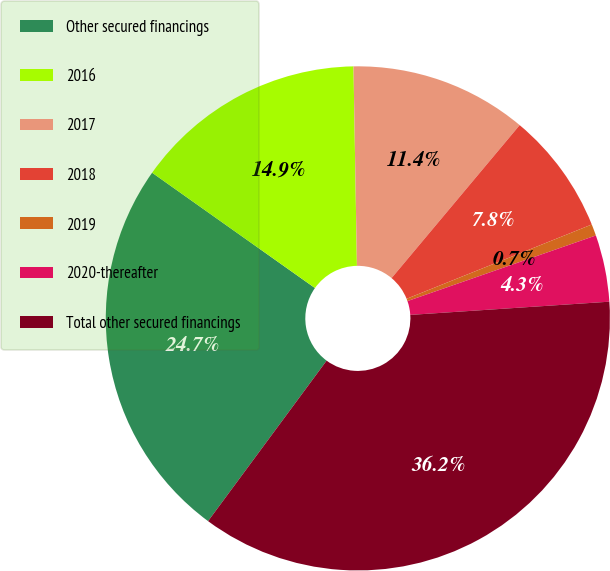Convert chart. <chart><loc_0><loc_0><loc_500><loc_500><pie_chart><fcel>Other secured financings<fcel>2016<fcel>2017<fcel>2018<fcel>2019<fcel>2020-thereafter<fcel>Total other secured financings<nl><fcel>24.68%<fcel>14.92%<fcel>11.37%<fcel>7.83%<fcel>0.74%<fcel>4.28%<fcel>36.18%<nl></chart> 